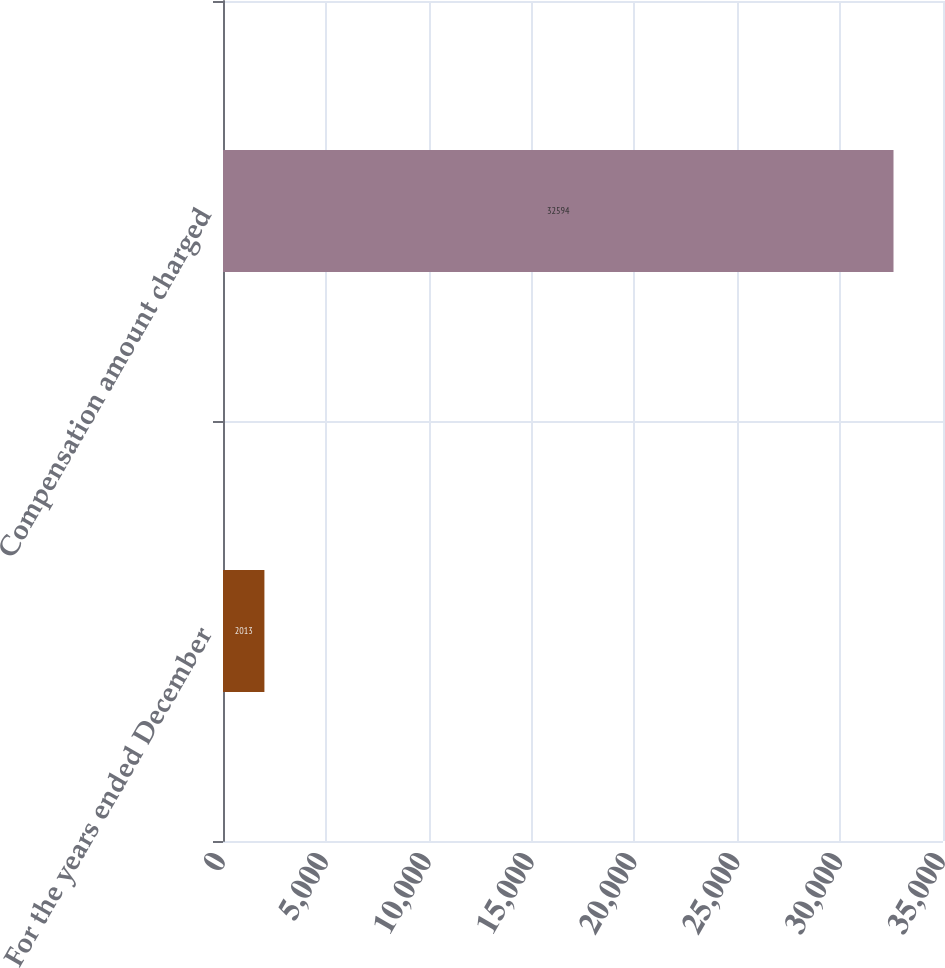Convert chart. <chart><loc_0><loc_0><loc_500><loc_500><bar_chart><fcel>For the years ended December<fcel>Compensation amount charged<nl><fcel>2013<fcel>32594<nl></chart> 